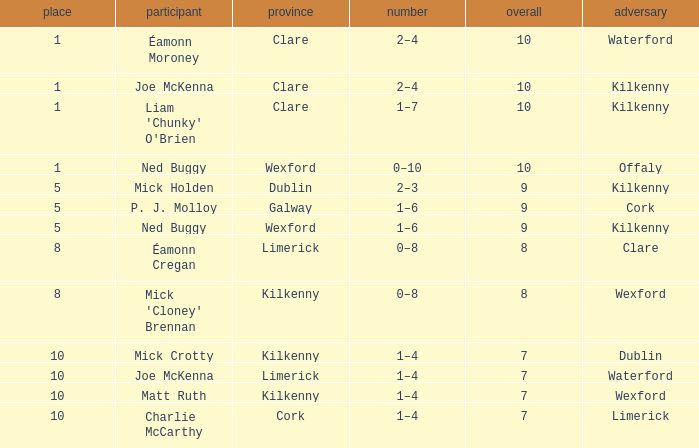Which Total has a County of kilkenny, and a Tally of 1–4, and a Rank larger than 10? None. 